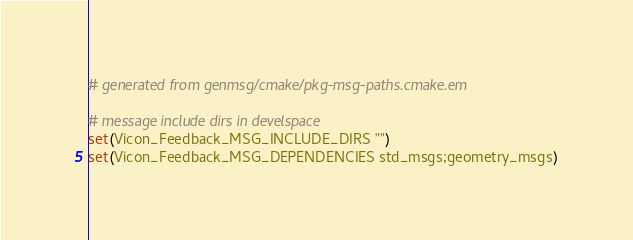<code> <loc_0><loc_0><loc_500><loc_500><_CMake_># generated from genmsg/cmake/pkg-msg-paths.cmake.em

# message include dirs in develspace
set(Vicon_Feedback_MSG_INCLUDE_DIRS "")
set(Vicon_Feedback_MSG_DEPENDENCIES std_msgs;geometry_msgs)
</code> 